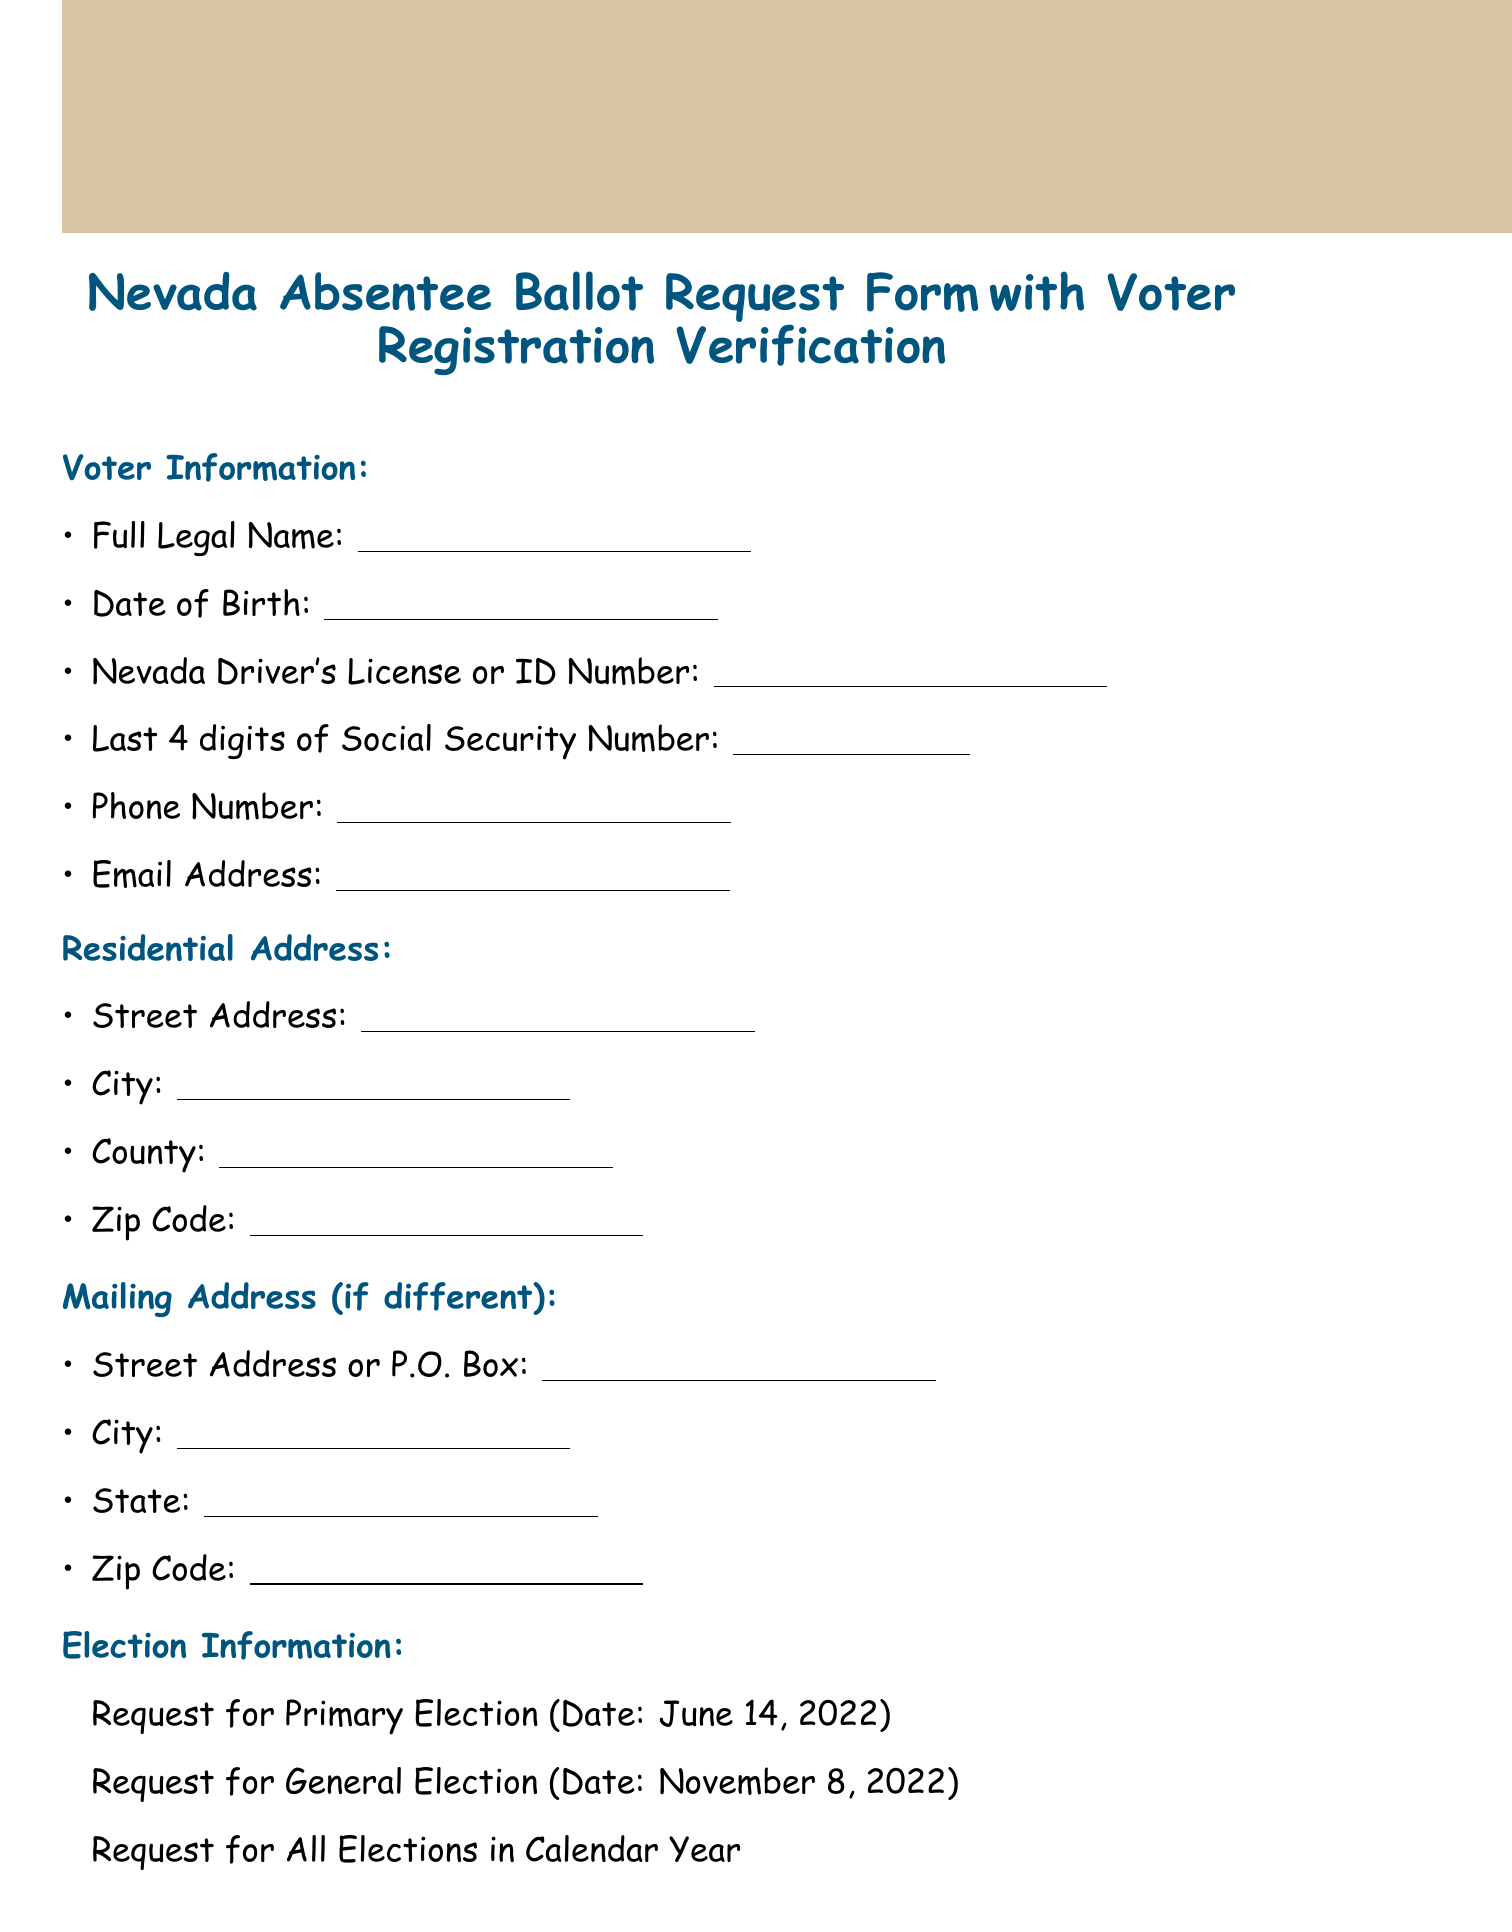What is the title of the form? The title of the form is presented at the beginning of the document, which includes both the purpose and type of the form.
Answer: Nevada Absentee Ballot Request Form with Voter Registration Verification What is the deadline for absentee ballot requests? The deadline is stated clearly in the additional information section of the document.
Answer: 5:00 PM on the 14th day before the election What is the mailing address for the County Clerk/Registrar of Voters Office? The mailing address is provided in the submission methods section, indicating where forms should be sent.
Answer: 123 Main Street, Tonopah, NV 89049 What should be checked to verify voter registration? This section includes necessary statements for verifying eligibility to vote.
Answer: I am a citizen of the United States How many elections can you request an absentee ballot for? The election information section specifies the options for ballot requests.
Answer: All Elections in Calendar Year Who is the county clerk mentioned in local resources? The section provides a local resource contact for residents needing assistance with voting matters.
Answer: Jane Smith What is the phone number for assistance with the form? The phone number is given in the additional information section for those needing help.
Answer: (775) 684-5705 What is one of the methods for submitting the request form? Various submission methods are listed, providing options for how to send the form.
Answer: Online What is the date of the primary election mentioned in the document? The election dates are included in the election information section for clarity.
Answer: June 14, 2022 